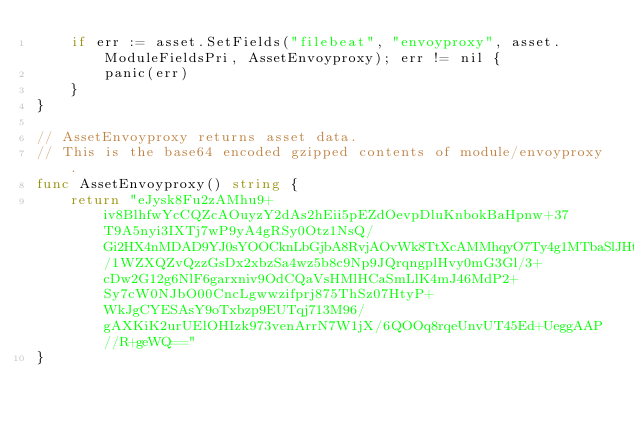Convert code to text. <code><loc_0><loc_0><loc_500><loc_500><_Go_>	if err := asset.SetFields("filebeat", "envoyproxy", asset.ModuleFieldsPri, AssetEnvoyproxy); err != nil {
		panic(err)
	}
}

// AssetEnvoyproxy returns asset data.
// This is the base64 encoded gzipped contents of module/envoyproxy.
func AssetEnvoyproxy() string {
	return "eJysk8Fu2zAMhu9+iv8BlhfwYcCQZcAOuyzY2dAs2hEii5pEZdOevpDluKnbokBaHpnw+37T9A5nyi3IXTj7wP9yA4gRSy0Otz1NsQ/Gi2HX4nMDAD9YJ0sYOOCknLbGjbA8RvjAOvWk8TtXcAMMhqyO7Ty4g1MTbaSlJHtqMQZOfum8oC31baZhCDxVCmZM1atBKMBxmJQ1/1WZXQZvQzzGsDx2xbzSa4wz5b8c9Np9JQrqngplHvy0mG3Gl/3+cDw2G12g6NlF6garxniv9OdCQaVsHMlHCaSmLlK4mJ46MdP2+Sy7cW0NJbO00CncLgwwzifprj875ThSz07HtyP+WkJgCYESAsY9oTxbzp9EUTqj713M96/gAXKiK2urUElOHIzk973venArrN7W1jX/6QOOq8rqeUnvUT45Ed+UeggAAP//R+geWQ=="
}
</code> 